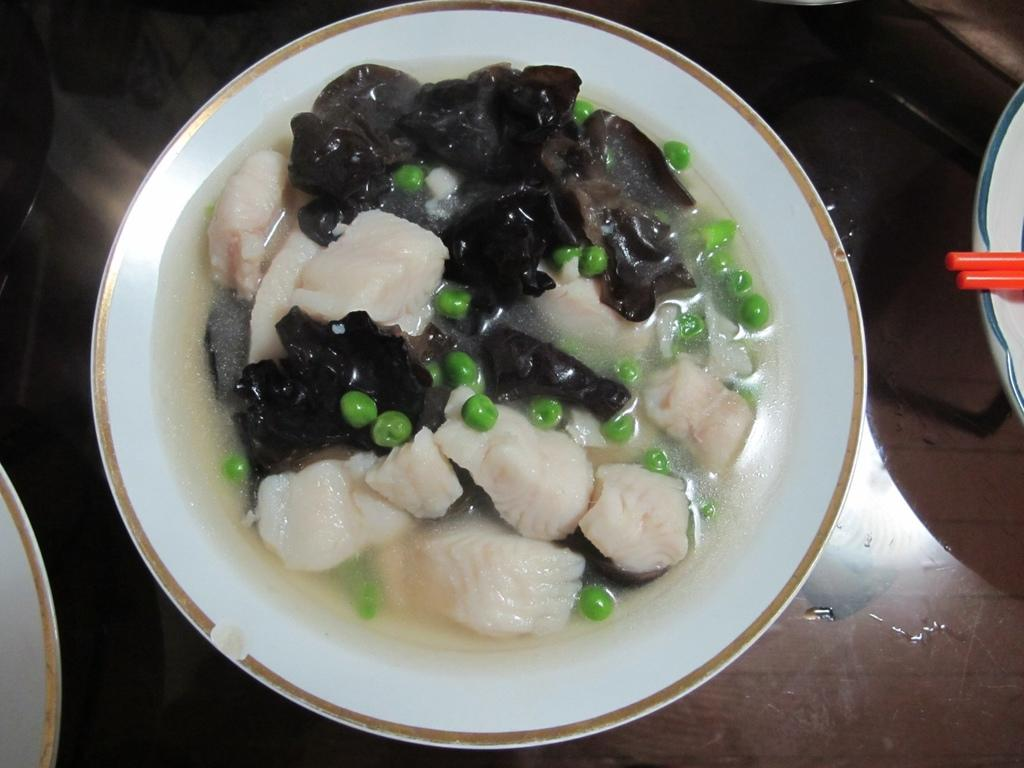What is in the bowl that is visible in the image? There is a bowl with food items in the image. Where is the bowl located in the image? The bowl is present on a table. Are there any other bowls visible in the image? Yes, there are other bowls present in the image. How many sticks are being held by the boys in the image? There are no boys or sticks present in the image. 